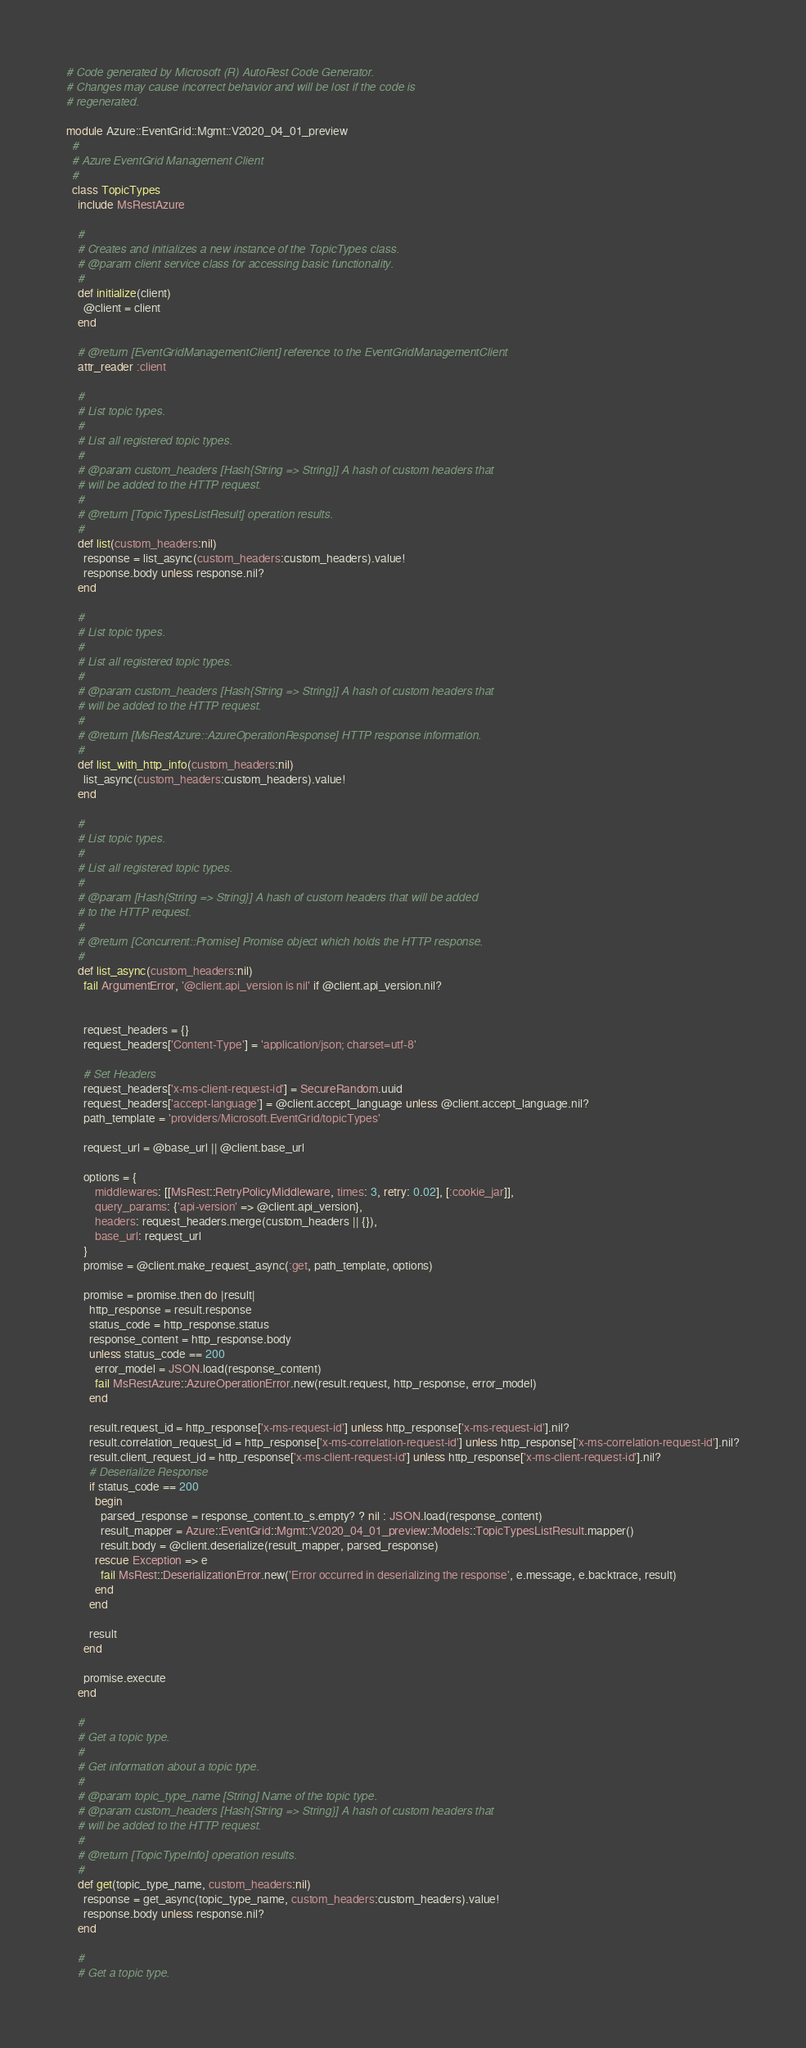<code> <loc_0><loc_0><loc_500><loc_500><_Ruby_># Code generated by Microsoft (R) AutoRest Code Generator.
# Changes may cause incorrect behavior and will be lost if the code is
# regenerated.

module Azure::EventGrid::Mgmt::V2020_04_01_preview
  #
  # Azure EventGrid Management Client
  #
  class TopicTypes
    include MsRestAzure

    #
    # Creates and initializes a new instance of the TopicTypes class.
    # @param client service class for accessing basic functionality.
    #
    def initialize(client)
      @client = client
    end

    # @return [EventGridManagementClient] reference to the EventGridManagementClient
    attr_reader :client

    #
    # List topic types.
    #
    # List all registered topic types.
    #
    # @param custom_headers [Hash{String => String}] A hash of custom headers that
    # will be added to the HTTP request.
    #
    # @return [TopicTypesListResult] operation results.
    #
    def list(custom_headers:nil)
      response = list_async(custom_headers:custom_headers).value!
      response.body unless response.nil?
    end

    #
    # List topic types.
    #
    # List all registered topic types.
    #
    # @param custom_headers [Hash{String => String}] A hash of custom headers that
    # will be added to the HTTP request.
    #
    # @return [MsRestAzure::AzureOperationResponse] HTTP response information.
    #
    def list_with_http_info(custom_headers:nil)
      list_async(custom_headers:custom_headers).value!
    end

    #
    # List topic types.
    #
    # List all registered topic types.
    #
    # @param [Hash{String => String}] A hash of custom headers that will be added
    # to the HTTP request.
    #
    # @return [Concurrent::Promise] Promise object which holds the HTTP response.
    #
    def list_async(custom_headers:nil)
      fail ArgumentError, '@client.api_version is nil' if @client.api_version.nil?


      request_headers = {}
      request_headers['Content-Type'] = 'application/json; charset=utf-8'

      # Set Headers
      request_headers['x-ms-client-request-id'] = SecureRandom.uuid
      request_headers['accept-language'] = @client.accept_language unless @client.accept_language.nil?
      path_template = 'providers/Microsoft.EventGrid/topicTypes'

      request_url = @base_url || @client.base_url

      options = {
          middlewares: [[MsRest::RetryPolicyMiddleware, times: 3, retry: 0.02], [:cookie_jar]],
          query_params: {'api-version' => @client.api_version},
          headers: request_headers.merge(custom_headers || {}),
          base_url: request_url
      }
      promise = @client.make_request_async(:get, path_template, options)

      promise = promise.then do |result|
        http_response = result.response
        status_code = http_response.status
        response_content = http_response.body
        unless status_code == 200
          error_model = JSON.load(response_content)
          fail MsRestAzure::AzureOperationError.new(result.request, http_response, error_model)
        end

        result.request_id = http_response['x-ms-request-id'] unless http_response['x-ms-request-id'].nil?
        result.correlation_request_id = http_response['x-ms-correlation-request-id'] unless http_response['x-ms-correlation-request-id'].nil?
        result.client_request_id = http_response['x-ms-client-request-id'] unless http_response['x-ms-client-request-id'].nil?
        # Deserialize Response
        if status_code == 200
          begin
            parsed_response = response_content.to_s.empty? ? nil : JSON.load(response_content)
            result_mapper = Azure::EventGrid::Mgmt::V2020_04_01_preview::Models::TopicTypesListResult.mapper()
            result.body = @client.deserialize(result_mapper, parsed_response)
          rescue Exception => e
            fail MsRest::DeserializationError.new('Error occurred in deserializing the response', e.message, e.backtrace, result)
          end
        end

        result
      end

      promise.execute
    end

    #
    # Get a topic type.
    #
    # Get information about a topic type.
    #
    # @param topic_type_name [String] Name of the topic type.
    # @param custom_headers [Hash{String => String}] A hash of custom headers that
    # will be added to the HTTP request.
    #
    # @return [TopicTypeInfo] operation results.
    #
    def get(topic_type_name, custom_headers:nil)
      response = get_async(topic_type_name, custom_headers:custom_headers).value!
      response.body unless response.nil?
    end

    #
    # Get a topic type.</code> 